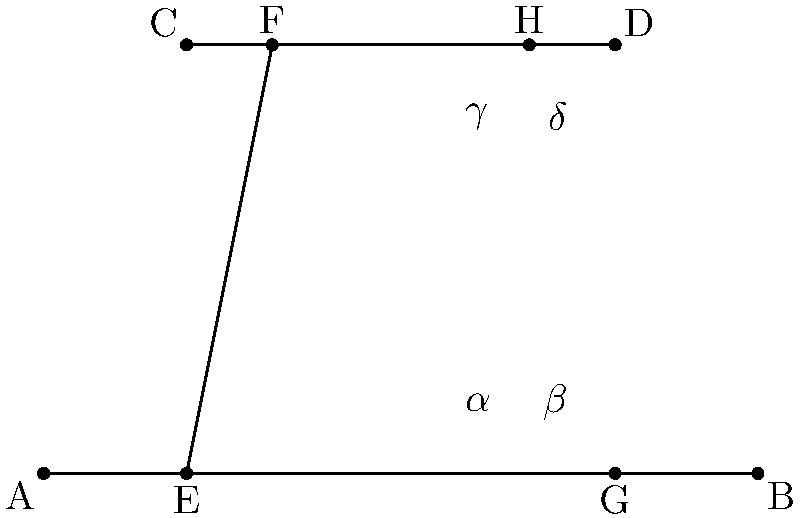In der Abbildung sehen wir zwei parallele Linien AB und CD, die von einer Transversale EF geschnitten werden. Johannes W. Betz, ein bekannter deutscher Mathematiker, hat oft über solche geometrischen Beziehungen nachgedacht. Wenn der Winkel $\alpha = 65°$ ist, wie groß ist dann der Winkel $\delta$? Um diese Frage zu beantworten, folgen wir diesen Schritten:

1. Erinnern wir uns an die Eigenschaften von Winkeln, die durch parallele Linien und eine Transversale gebildet werden:
   - Stufenwinkel sind gleich
   - Wechselwinkel sind gleich
   - Nebenwinkel ergänzen sich zu 180°

2. In diesem Fall sind $\alpha$ und $\gamma$ Stufenwinkel, also gilt:
   $\alpha = \gamma = 65°$

3. $\gamma$ und $\delta$ sind Nebenwinkel, also:
   $\gamma + \delta = 180°$

4. Setzen wir den Wert von $\gamma$ ein:
   $65° + \delta = 180°$

5. Lösen wir die Gleichung nach $\delta$ auf:
   $\delta = 180° - 65° = 115°$

Somit erhalten wir den Wert für den Winkel $\delta$.
Answer: $115°$ 